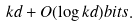Convert formula to latex. <formula><loc_0><loc_0><loc_500><loc_500>k d + O ( \log k d ) b i t s .</formula> 